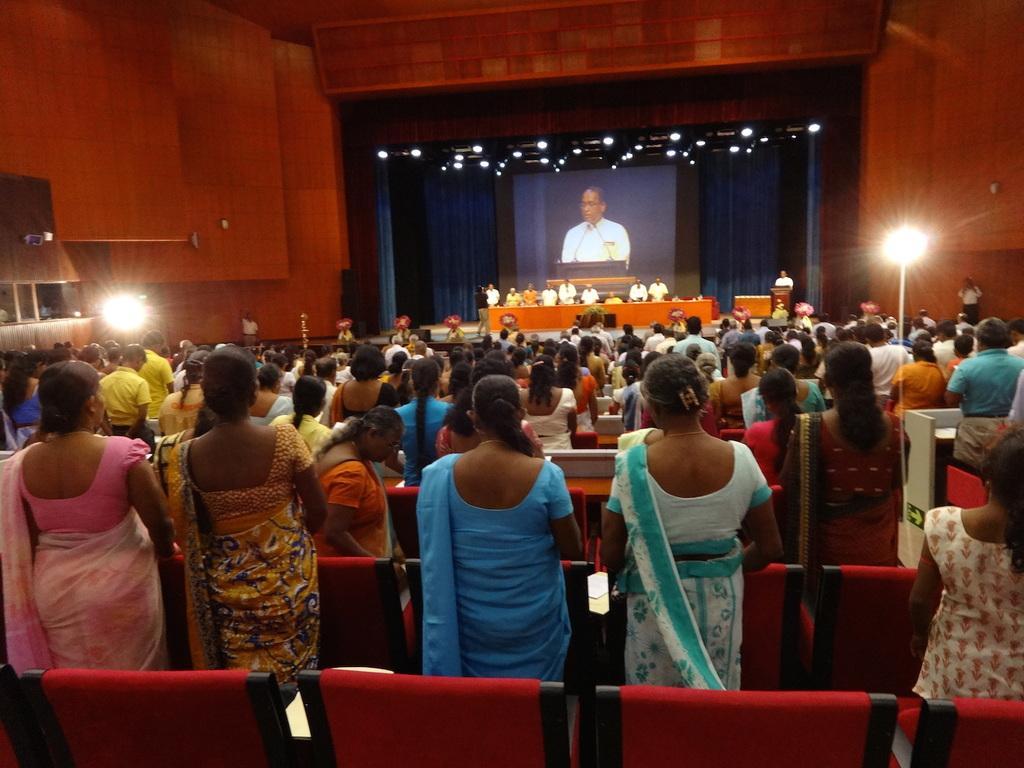Can you describe this image briefly? In this image I can see number of persons are standing and chairs which are red and black in color. In the background I can see the stage, few persons standing on the stage, a desk, few lights, a screen, the ceiling, the wall and the blue colored curtain. 